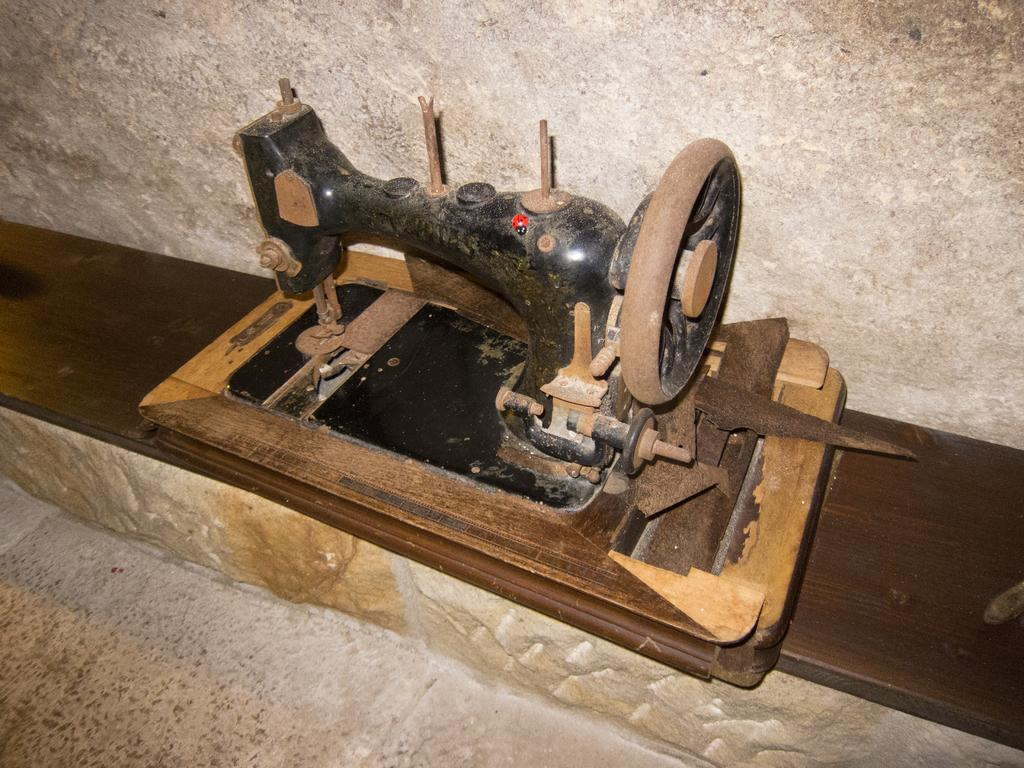What is the main object in the image? There is a sewing machine in the image. Where is the sewing machine placed? The sewing machine is on a wooden plank. What is the wooden plank resting on? The wooden plank is on a rock. What can be seen in the background of the image? There is a wall in the background of the image. What is visible at the bottom of the image? There is a floor visible at the bottom of the image. How many friends are helping the creator of the sewing machine in the image? There is no indication of friends or a creator in the image; it only shows a sewing machine on a wooden plank. What type of sticks are used to hold the sewing machine in place? There are no sticks visible in the image; the sewing machine is resting on a wooden plank and a rock. 